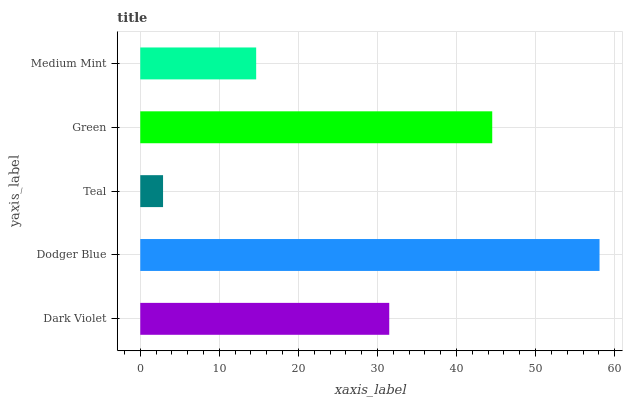Is Teal the minimum?
Answer yes or no. Yes. Is Dodger Blue the maximum?
Answer yes or no. Yes. Is Dodger Blue the minimum?
Answer yes or no. No. Is Teal the maximum?
Answer yes or no. No. Is Dodger Blue greater than Teal?
Answer yes or no. Yes. Is Teal less than Dodger Blue?
Answer yes or no. Yes. Is Teal greater than Dodger Blue?
Answer yes or no. No. Is Dodger Blue less than Teal?
Answer yes or no. No. Is Dark Violet the high median?
Answer yes or no. Yes. Is Dark Violet the low median?
Answer yes or no. Yes. Is Green the high median?
Answer yes or no. No. Is Medium Mint the low median?
Answer yes or no. No. 